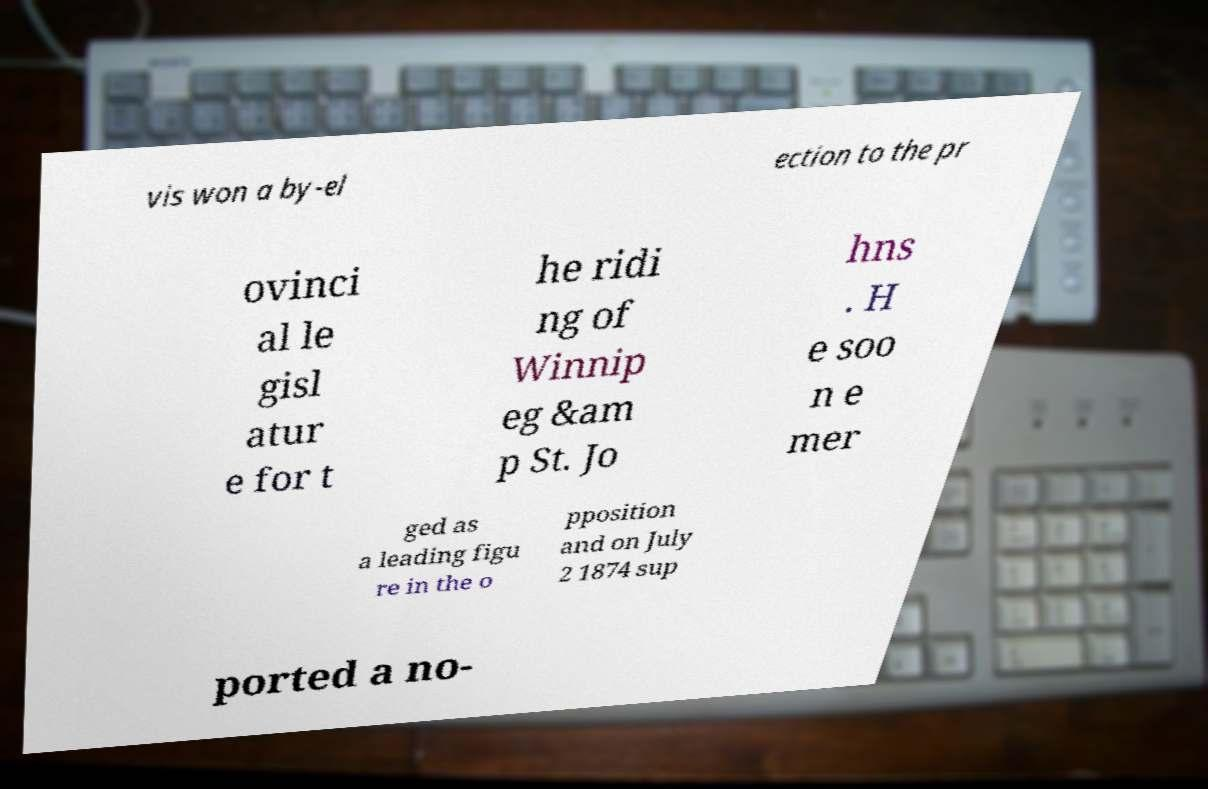I need the written content from this picture converted into text. Can you do that? vis won a by-el ection to the pr ovinci al le gisl atur e for t he ridi ng of Winnip eg &am p St. Jo hns . H e soo n e mer ged as a leading figu re in the o pposition and on July 2 1874 sup ported a no- 